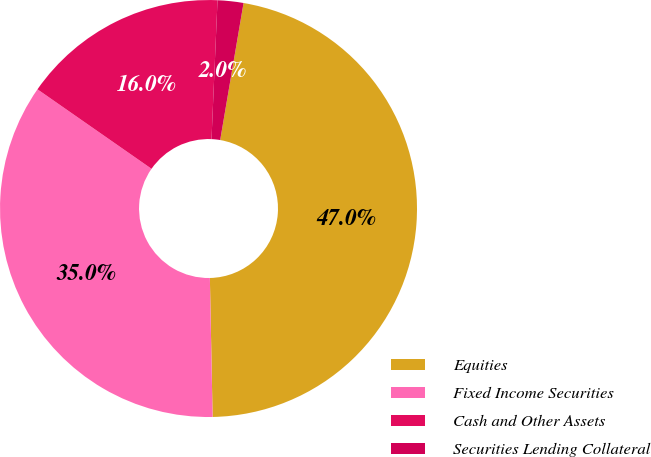<chart> <loc_0><loc_0><loc_500><loc_500><pie_chart><fcel>Equities<fcel>Fixed Income Securities<fcel>Cash and Other Assets<fcel>Securities Lending Collateral<nl><fcel>47.0%<fcel>35.0%<fcel>16.0%<fcel>2.0%<nl></chart> 